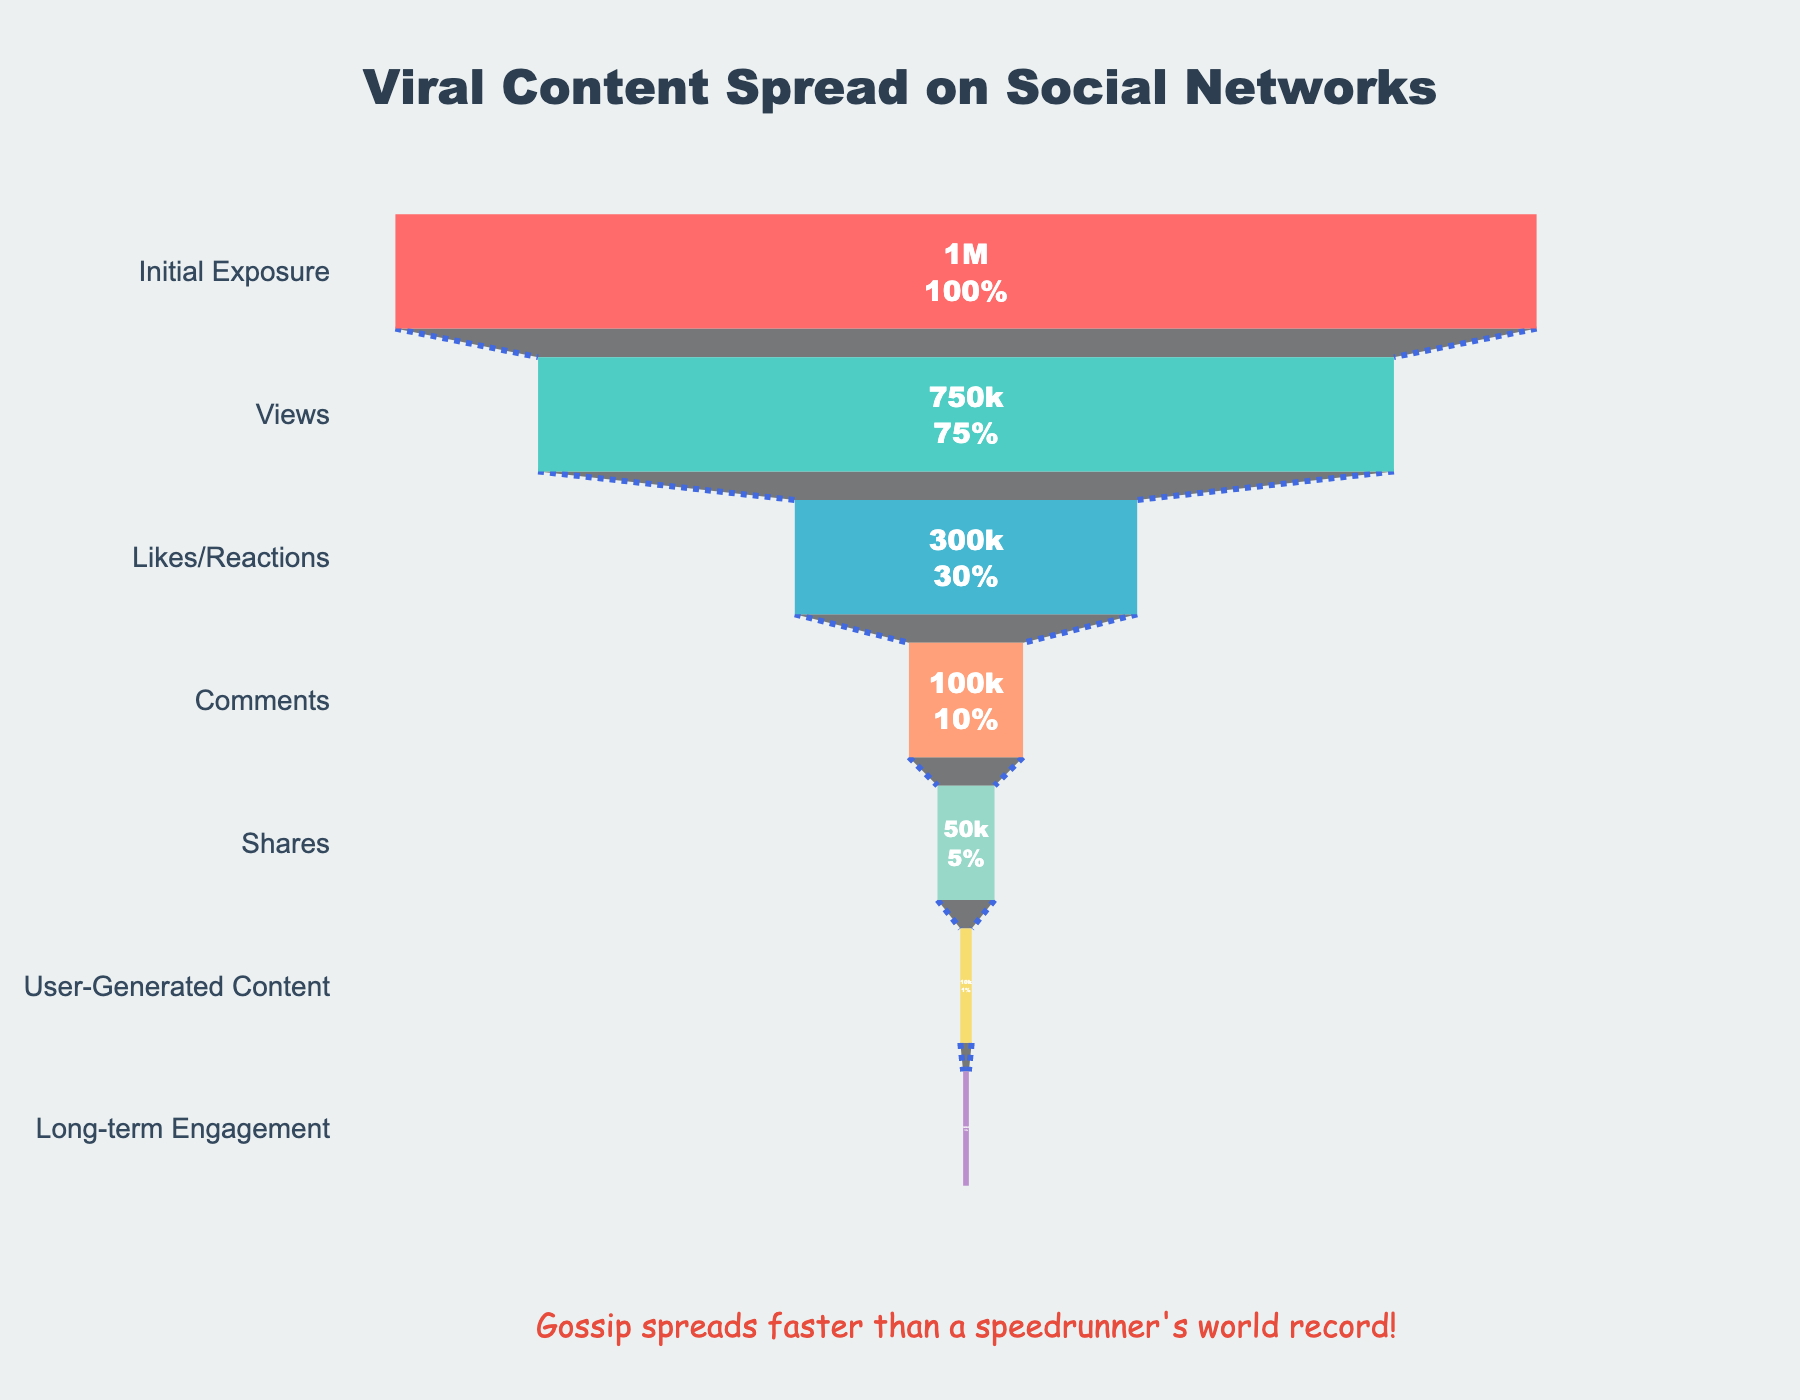What are the stages of viral content spread on the chart? Look at the y-axis labels of the funnel chart, which list the stages in order from top to bottom.
Answer: Initial Exposure, Views, Likes/Reactions, Comments, Shares, User-Generated Content, Long-term Engagement What is the retention percentage at the 'Likes/Reactions' stage? Check the retention percentage associated with the 'Likes/Reactions' stage on the funnel chart.
Answer: 30% How many users reached the 'Comments' stage? Find the user count corresponding to the 'Comments' stage on the chart.
Answer: 100,000 Which stage has the lowest user retention? Identify the stage with the smallest retention percentage in the funnel chart.
Answer: Long-term Engagement How does the number of users at the 'Shares' stage compare to the 'Likes/Reactions' stage? Compare the user counts at the 'Shares' and 'Likes/Reactions' stages which can be found on the chart.
Answer: 50,000 vs. 300,000 What is the difference in the number of users between the 'Views' and 'Initial Exposure' stages? Subtract the user count at the 'Views' stage from the user count at the 'Initial Exposure' stage.
Answer: 250,000 What is the total drop-off percentage from 'Initial Exposure' to 'Shares'? Calculate the drop in retention from 'Initial Exposure' (100%) to 'Shares' (5%) by finding the difference.
Answer: 95% Which stage in the funnel sees the highest drop-off in user retention from the previous stage? Identify the stage where the largest reduction in retention percentage occurs from the previous stage by comparing the consecutive stages.
Answer: From Views to Likes/Reactions (75% to 30%) How does the user retention at 'User-Generated Content' compare to 'Comments'? Examine the retention percentages of 'User-Generated Content' and 'Comments' stages and compare them.
Answer: 1% vs. 10% What is the retention difference between 'Views' and 'Long-term Engagement'? Subtract the retention percentage of 'Long-term Engagement' from that of 'Views'.
Answer: 74.5% 